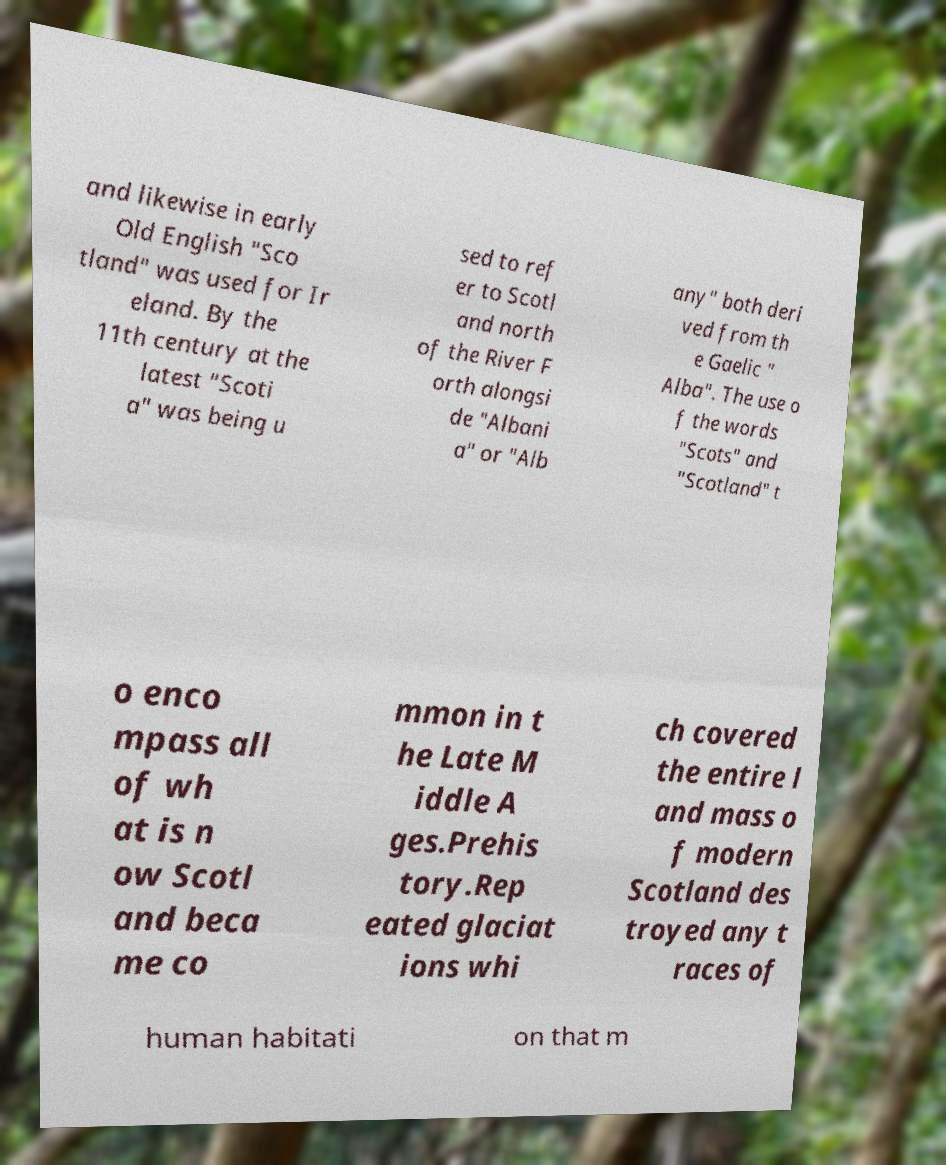Could you extract and type out the text from this image? and likewise in early Old English "Sco tland" was used for Ir eland. By the 11th century at the latest "Scoti a" was being u sed to ref er to Scotl and north of the River F orth alongsi de "Albani a" or "Alb any" both deri ved from th e Gaelic " Alba". The use o f the words "Scots" and "Scotland" t o enco mpass all of wh at is n ow Scotl and beca me co mmon in t he Late M iddle A ges.Prehis tory.Rep eated glaciat ions whi ch covered the entire l and mass o f modern Scotland des troyed any t races of human habitati on that m 